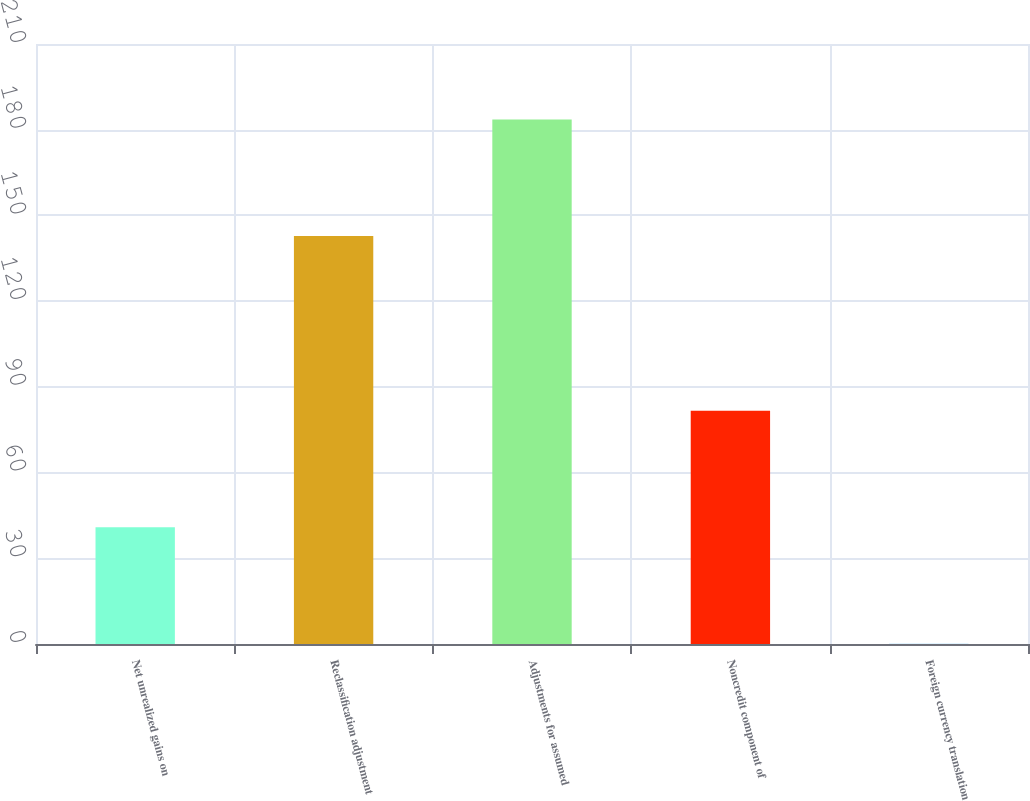Convert chart to OTSL. <chart><loc_0><loc_0><loc_500><loc_500><bar_chart><fcel>Net unrealized gains on<fcel>Reclassification adjustment<fcel>Adjustments for assumed<fcel>Noncredit component of<fcel>Foreign currency translation<nl><fcel>40.88<fcel>142.83<fcel>183.61<fcel>81.66<fcel>0.1<nl></chart> 